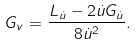Convert formula to latex. <formula><loc_0><loc_0><loc_500><loc_500>G _ { v } = \frac { L _ { \dot { u } } - 2 \dot { u } G _ { \dot { u } } } { 8 \dot { u } ^ { 2 } } .</formula> 